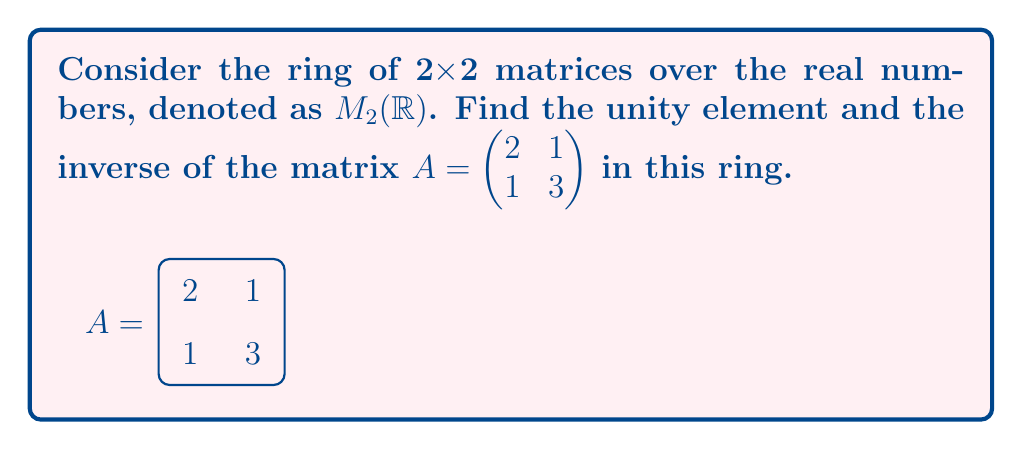Teach me how to tackle this problem. 1. Unity element:
   The unity element in the ring of 2x2 matrices is the identity matrix:
   $$I = \begin{pmatrix} 1 & 0 \\ 0 & 1 \end{pmatrix}$$

2. Inverse of matrix A:
   To find the inverse of A, we use the formula:
   $$A^{-1} = \frac{1}{det(A)} \begin{pmatrix} d & -b \\ -c & a \end{pmatrix}$$
   where $A = \begin{pmatrix} a & b \\ c & d \end{pmatrix}$

   Step 1: Calculate the determinant of A
   $det(A) = ad - bc = (2)(3) - (1)(1) = 6 - 1 = 5$

   Step 2: Apply the inverse formula
   $$A^{-1} = \frac{1}{5} \begin{pmatrix} 3 & -1 \\ -1 & 2 \end{pmatrix}$$

   Step 3: Simplify
   $$A^{-1} = \begin{pmatrix} 3/5 & -1/5 \\ -1/5 & 2/5 \end{pmatrix}$$

Verification:
To verify, multiply A and $A^{-1}$:
$$AA^{-1} = \begin{pmatrix} 2 & 1 \\ 1 & 3 \end{pmatrix} \begin{pmatrix} 3/5 & -1/5 \\ -1/5 & 2/5 \end{pmatrix} = \begin{pmatrix} 1 & 0 \\ 0 & 1 \end{pmatrix} = I$$

This confirms that we've found the correct inverse.
Answer: Unity element: $\begin{pmatrix} 1 & 0 \\ 0 & 1 \end{pmatrix}$, Inverse of A: $\begin{pmatrix} 3/5 & -1/5 \\ -1/5 & 2/5 \end{pmatrix}$ 